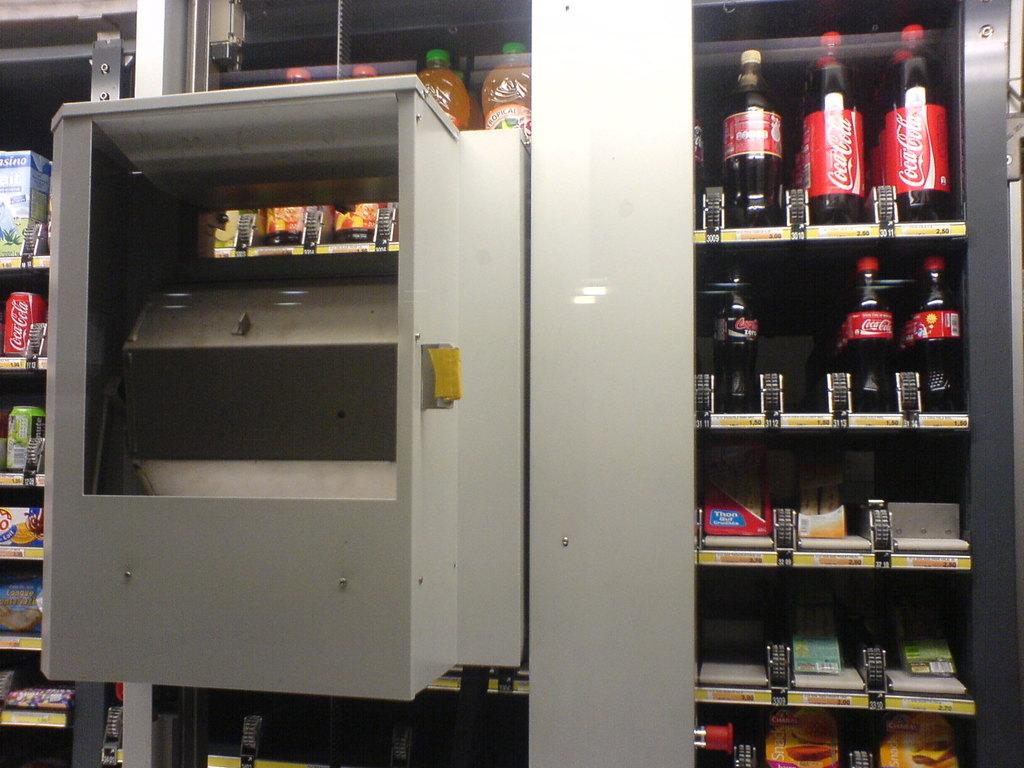Provide a one-sentence caption for the provided image. The vending machine stocks different Coca Cola products. 